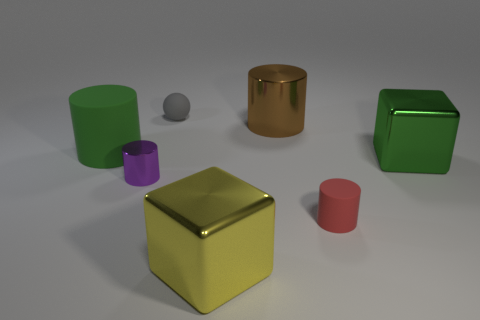Add 2 purple things. How many objects exist? 9 Subtract all spheres. How many objects are left? 6 Subtract all large green matte things. Subtract all big shiny cylinders. How many objects are left? 5 Add 7 purple cylinders. How many purple cylinders are left? 8 Add 5 brown objects. How many brown objects exist? 6 Subtract 0 cyan balls. How many objects are left? 7 